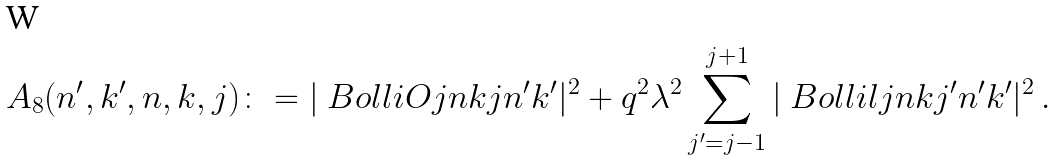<formula> <loc_0><loc_0><loc_500><loc_500>A _ { 8 } ( n ^ { \prime } , k ^ { \prime } , n , k , j ) \colon = | \ B o l l i O { j } { n } { k } { j } { n ^ { \prime } } { k ^ { \prime } } | ^ { 2 } + q ^ { 2 } \lambda ^ { 2 } \sum _ { j ^ { \prime } = j - 1 } ^ { j + 1 } | \ B o l l i l { j } { n } { k } { j ^ { \prime } } { n ^ { \prime } } { k ^ { \prime } } | ^ { 2 } \, .</formula> 